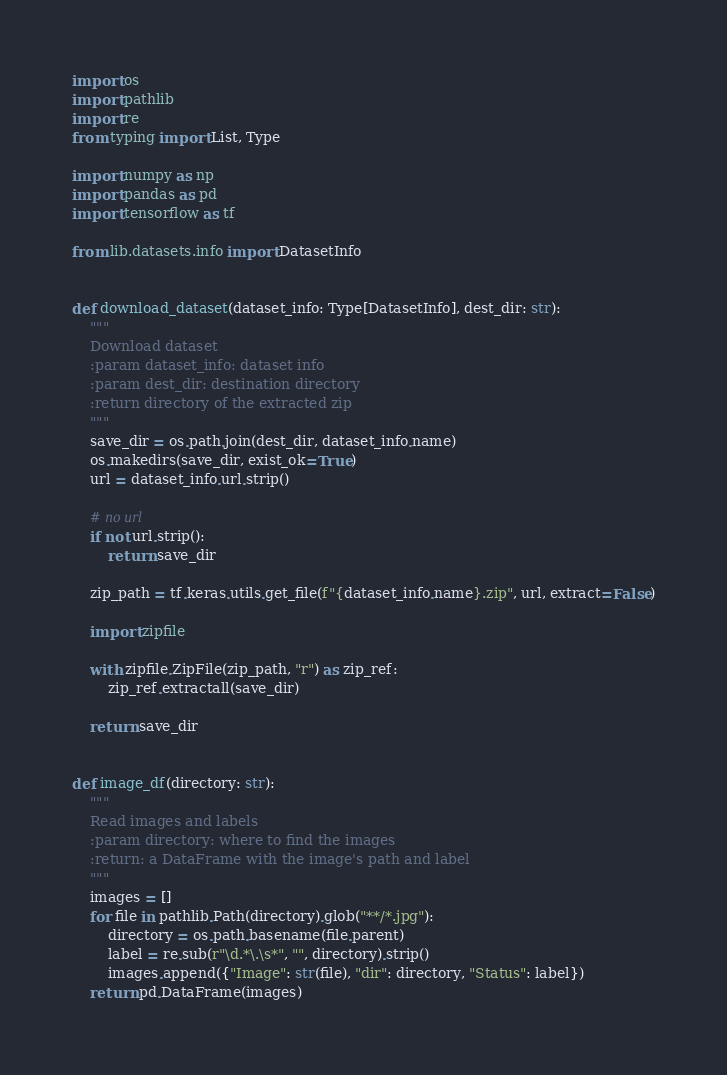Convert code to text. <code><loc_0><loc_0><loc_500><loc_500><_Python_>import os
import pathlib
import re
from typing import List, Type

import numpy as np
import pandas as pd
import tensorflow as tf

from lib.datasets.info import DatasetInfo


def download_dataset(dataset_info: Type[DatasetInfo], dest_dir: str):
    """
    Download dataset
    :param dataset_info: dataset info
    :param dest_dir: destination directory
    :return directory of the extracted zip
    """
    save_dir = os.path.join(dest_dir, dataset_info.name)
    os.makedirs(save_dir, exist_ok=True)
    url = dataset_info.url.strip()

    # no url
    if not url.strip():
        return save_dir

    zip_path = tf.keras.utils.get_file(f"{dataset_info.name}.zip", url, extract=False)

    import zipfile

    with zipfile.ZipFile(zip_path, "r") as zip_ref:
        zip_ref.extractall(save_dir)

    return save_dir


def image_df(directory: str):
    """
    Read images and labels
    :param directory: where to find the images
    :return: a DataFrame with the image's path and label
    """
    images = []
    for file in pathlib.Path(directory).glob("**/*.jpg"):
        directory = os.path.basename(file.parent)
        label = re.sub(r"\d.*\.\s*", "", directory).strip()
        images.append({"Image": str(file), "dir": directory, "Status": label})
    return pd.DataFrame(images)

</code> 